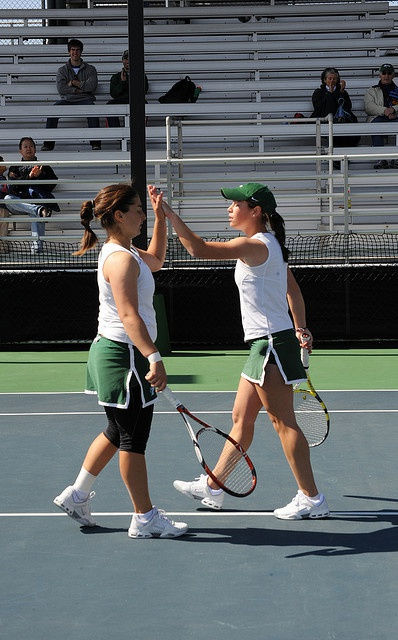Describe the objects in this image and their specific colors. I can see people in darkgray, black, maroon, and white tones, people in darkgray, maroon, black, and white tones, tennis racket in darkgray, gray, and black tones, people in darkgray, black, gray, and maroon tones, and people in darkgray, black, and gray tones in this image. 